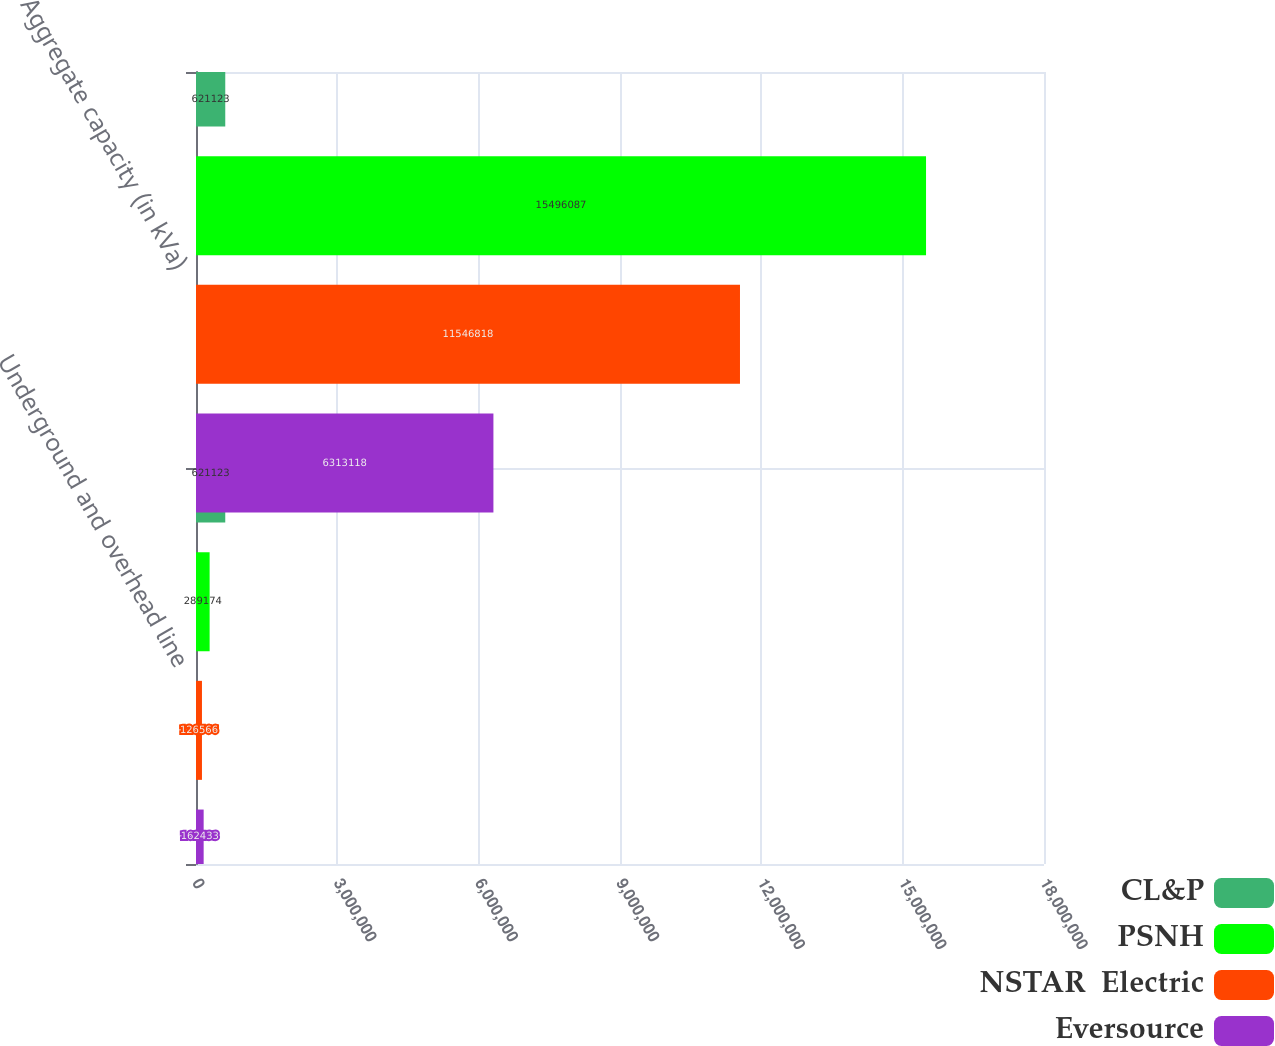Convert chart. <chart><loc_0><loc_0><loc_500><loc_500><stacked_bar_chart><ecel><fcel>Underground and overhead line<fcel>Aggregate capacity (in kVa)<nl><fcel>CL&P<fcel>621123<fcel>621123<nl><fcel>PSNH<fcel>289174<fcel>1.54961e+07<nl><fcel>NSTAR  Electric<fcel>126566<fcel>1.15468e+07<nl><fcel>Eversource<fcel>162433<fcel>6.31312e+06<nl></chart> 